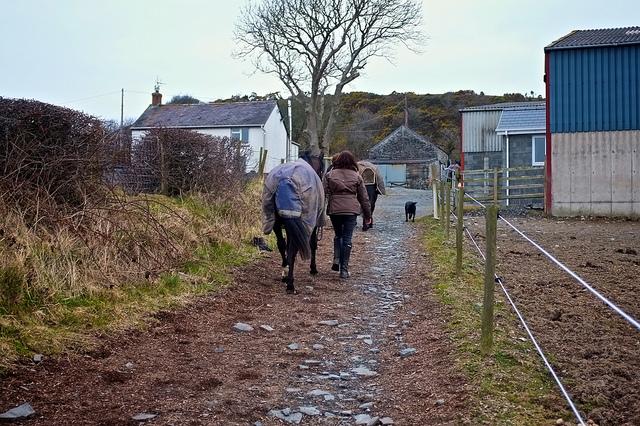Are these wild or domestic animals?
Keep it brief. Domestic. Where was this photo taken?
Give a very brief answer. Farm. What kind of animal is the lady walking with?
Answer briefly. Horse. Is someone on the horse?
Concise answer only. No. Does this path look muddy?
Concise answer only. Yes. What color boots is the woman on the right wearing?
Give a very brief answer. Black. Is this a city?
Quick response, please. No. What color is the ladies shirt?
Concise answer only. Brown. 